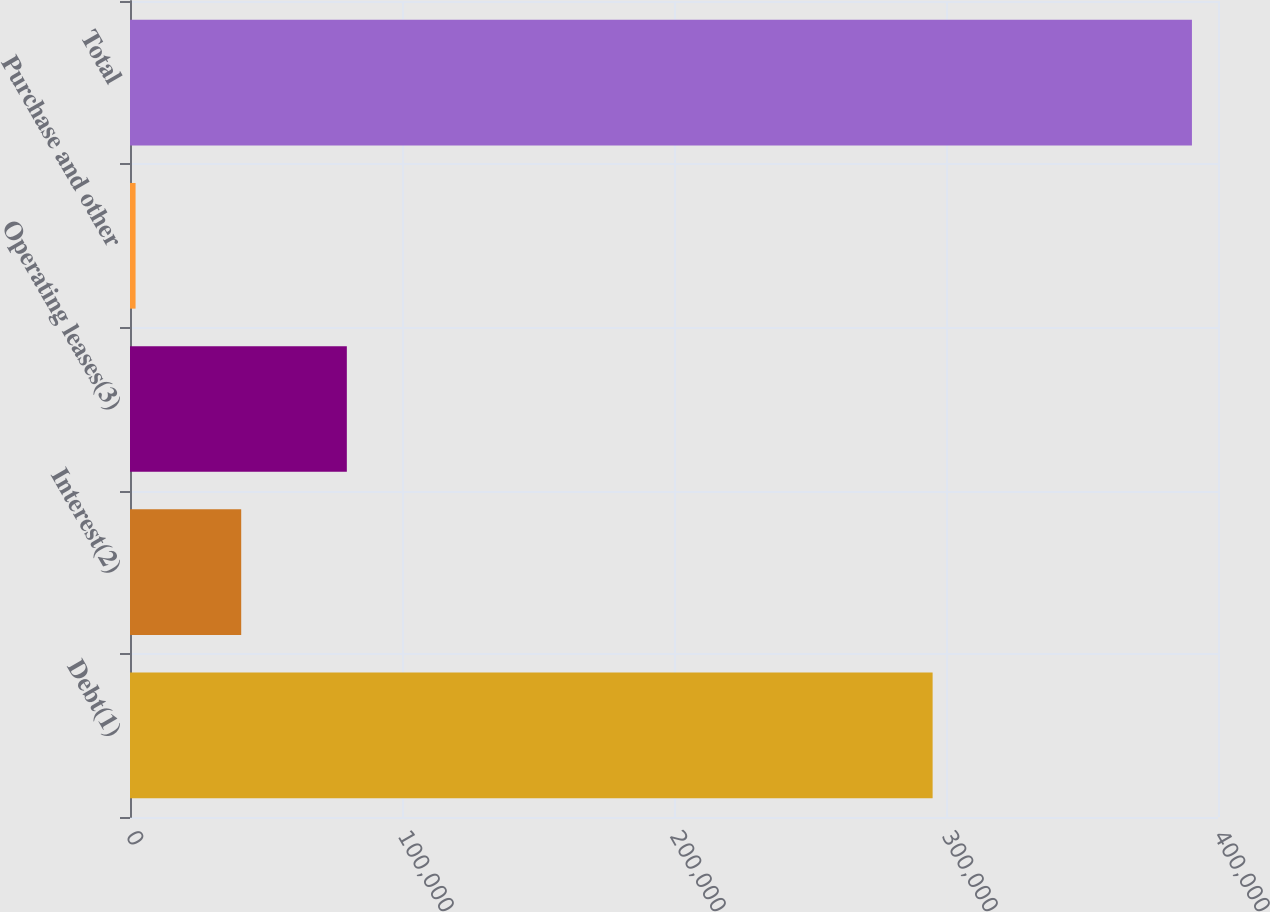<chart> <loc_0><loc_0><loc_500><loc_500><bar_chart><fcel>Debt(1)<fcel>Interest(2)<fcel>Operating leases(3)<fcel>Purchase and other<fcel>Total<nl><fcel>295080<fcel>40881.3<fcel>79718.6<fcel>2044<fcel>390417<nl></chart> 